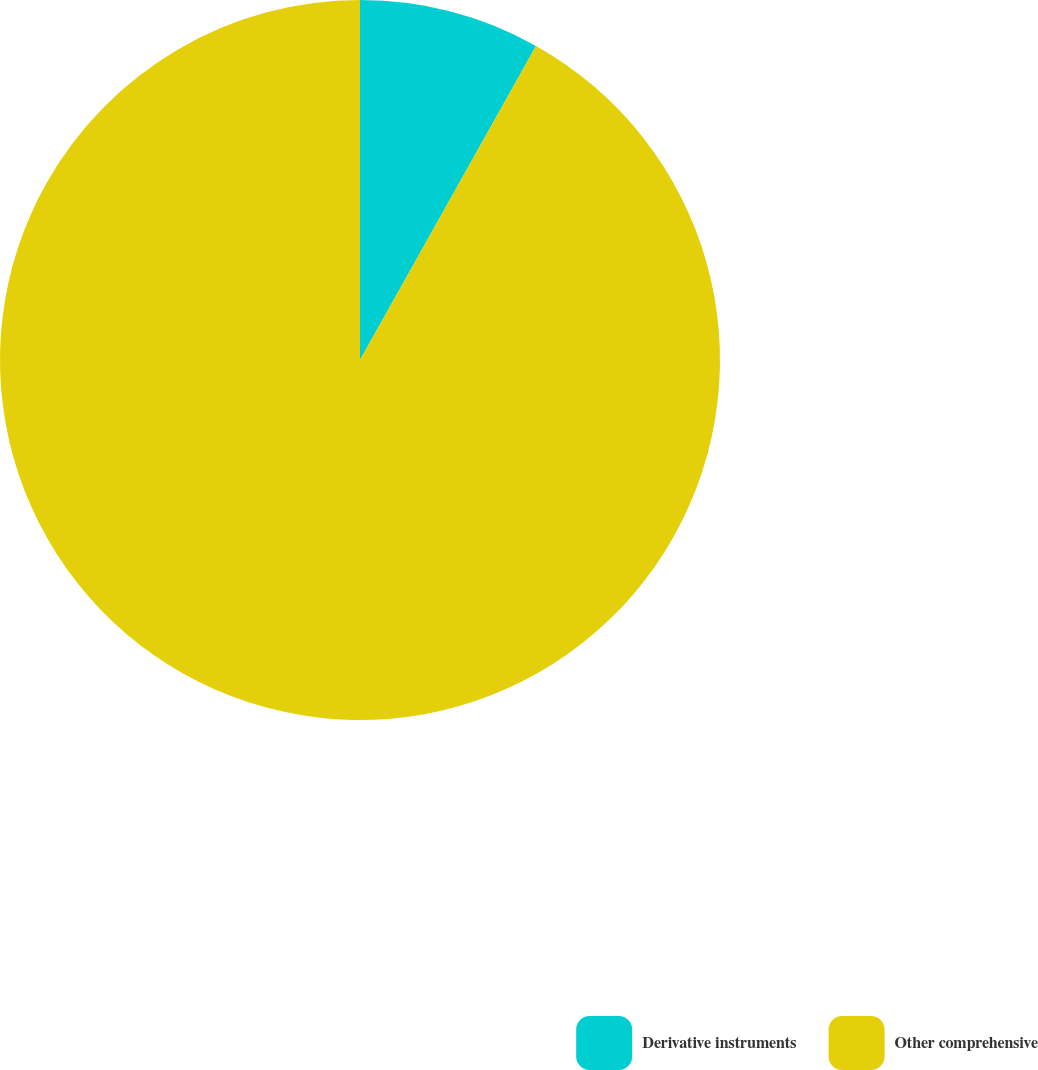Convert chart to OTSL. <chart><loc_0><loc_0><loc_500><loc_500><pie_chart><fcel>Derivative instruments<fcel>Other comprehensive<nl><fcel>8.13%<fcel>91.87%<nl></chart> 